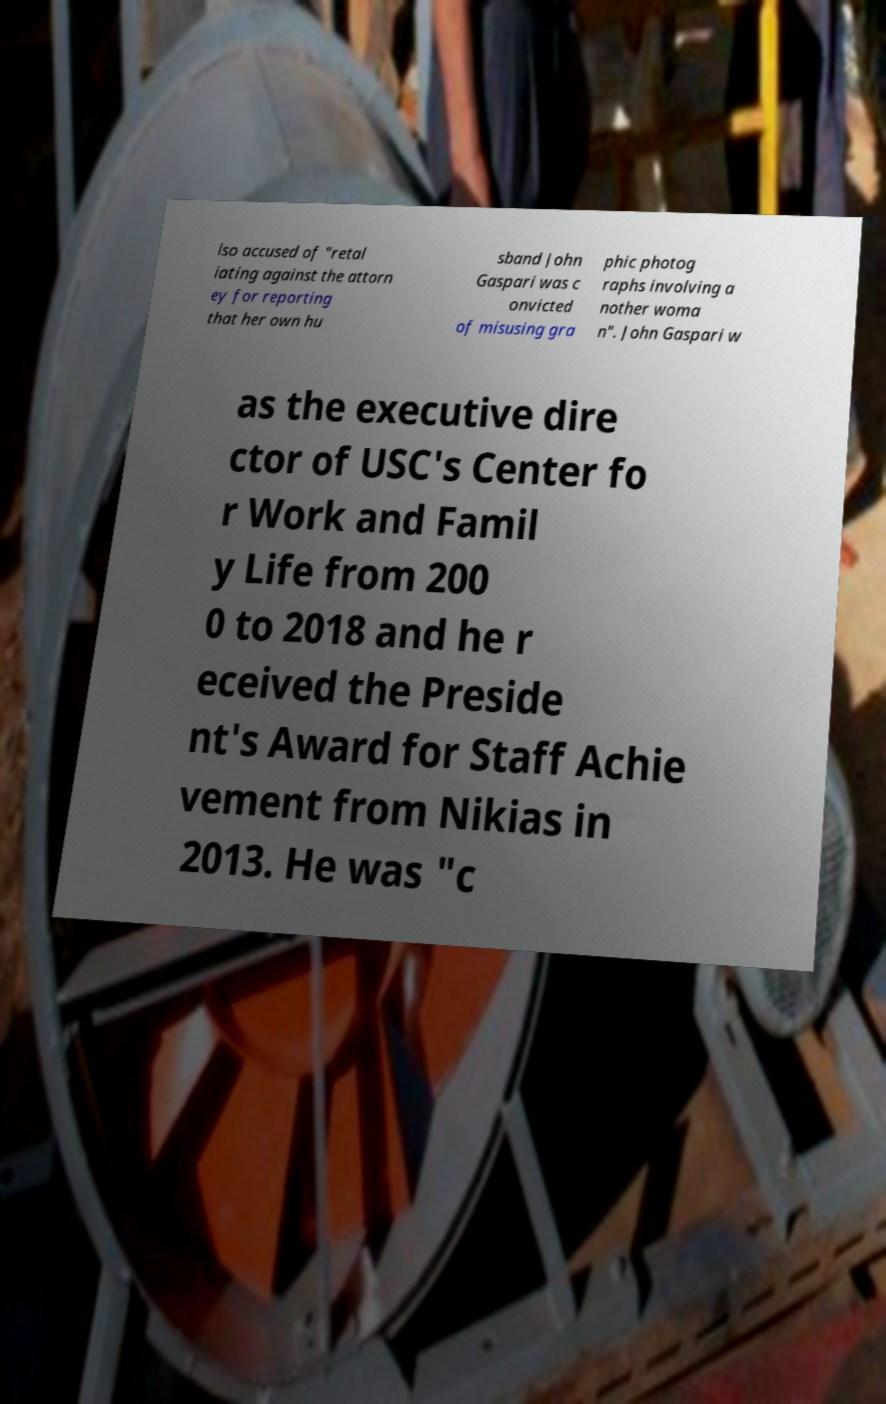Could you extract and type out the text from this image? lso accused of "retal iating against the attorn ey for reporting that her own hu sband John Gaspari was c onvicted of misusing gra phic photog raphs involving a nother woma n". John Gaspari w as the executive dire ctor of USC's Center fo r Work and Famil y Life from 200 0 to 2018 and he r eceived the Preside nt's Award for Staff Achie vement from Nikias in 2013. He was "c 